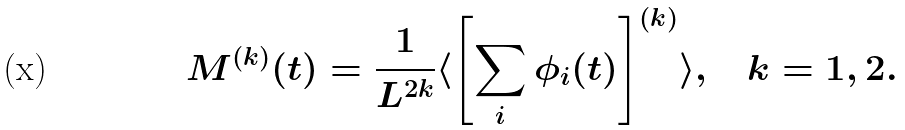Convert formula to latex. <formula><loc_0><loc_0><loc_500><loc_500>M ^ { ( k ) } ( t ) = \frac { 1 } { L ^ { 2 k } } \langle \left [ \sum _ { i } \phi _ { i } ( t ) \right ] ^ { ( k ) } \rangle , \quad k = 1 , 2 .</formula> 